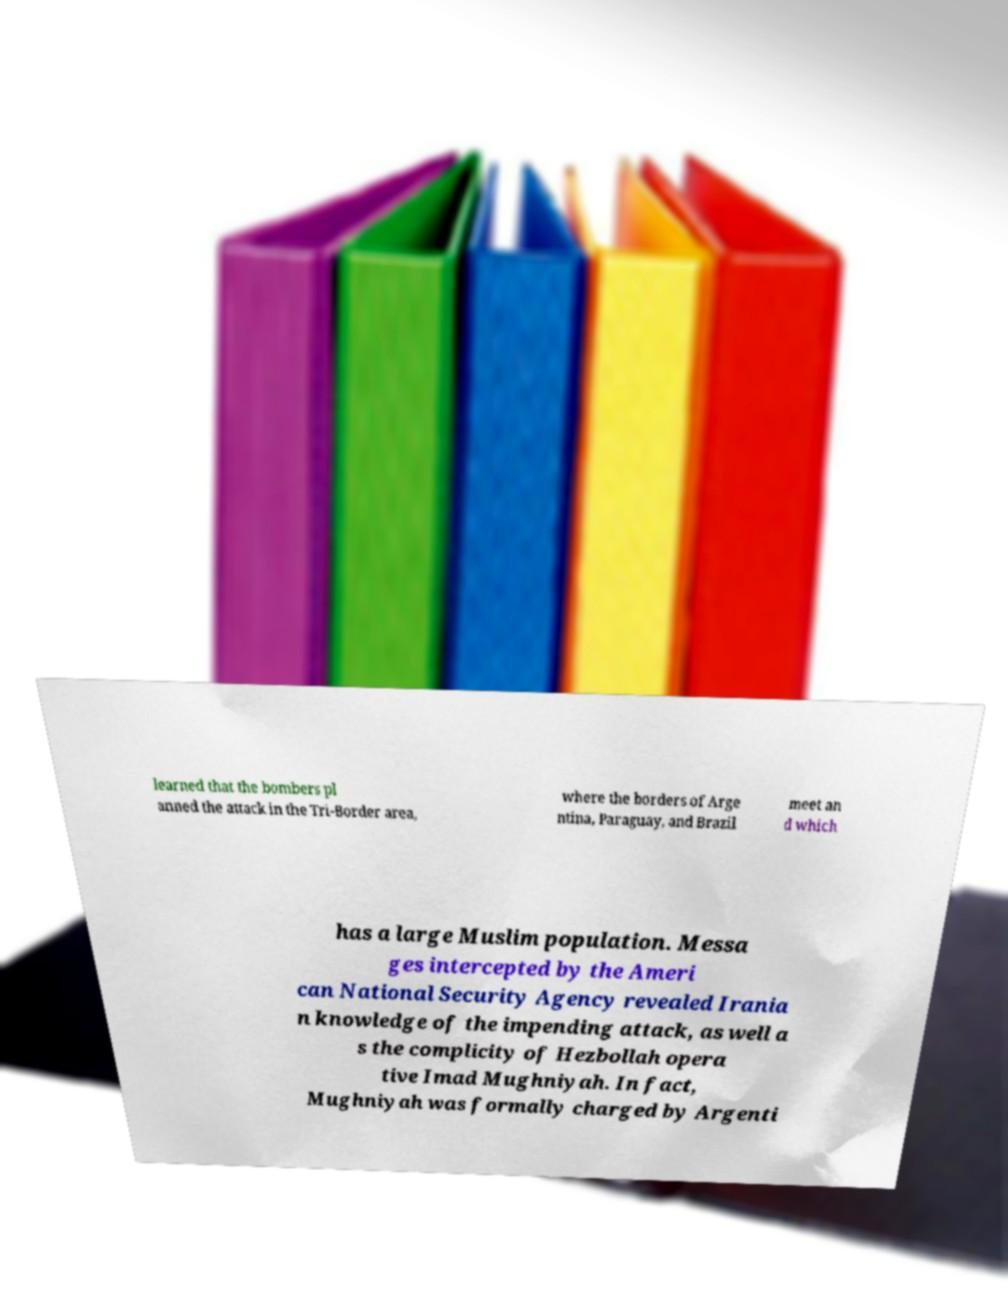Can you read and provide the text displayed in the image?This photo seems to have some interesting text. Can you extract and type it out for me? learned that the bombers pl anned the attack in the Tri-Border area, where the borders of Arge ntina, Paraguay, and Brazil meet an d which has a large Muslim population. Messa ges intercepted by the Ameri can National Security Agency revealed Irania n knowledge of the impending attack, as well a s the complicity of Hezbollah opera tive Imad Mughniyah. In fact, Mughniyah was formally charged by Argenti 